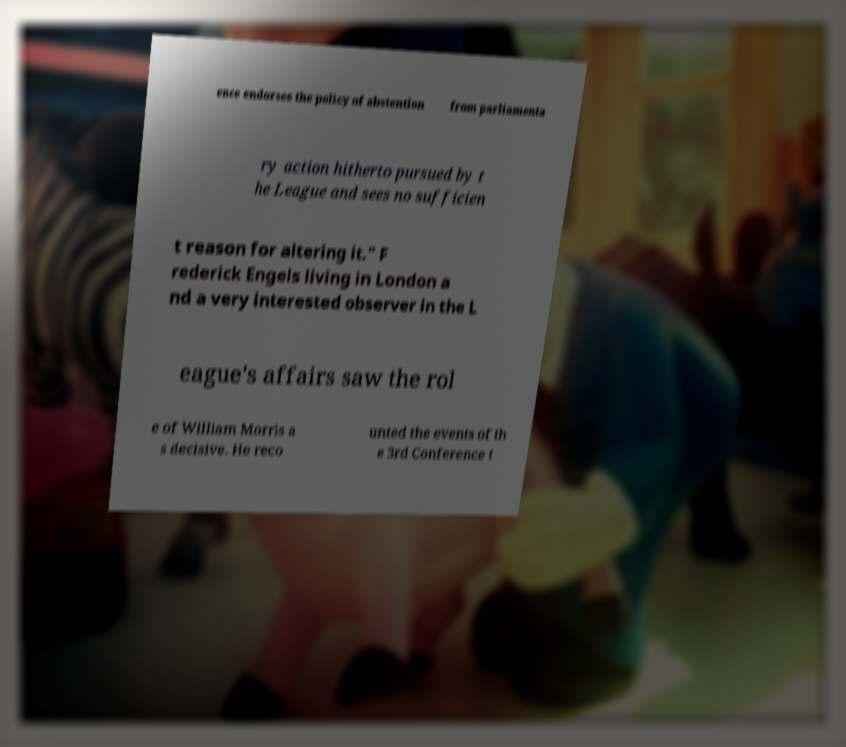For documentation purposes, I need the text within this image transcribed. Could you provide that? ence endorses the policy of abstention from parliamenta ry action hitherto pursued by t he League and sees no sufficien t reason for altering it." F rederick Engels living in London a nd a very interested observer in the L eague's affairs saw the rol e of William Morris a s decisive. He reco unted the events of th e 3rd Conference t 